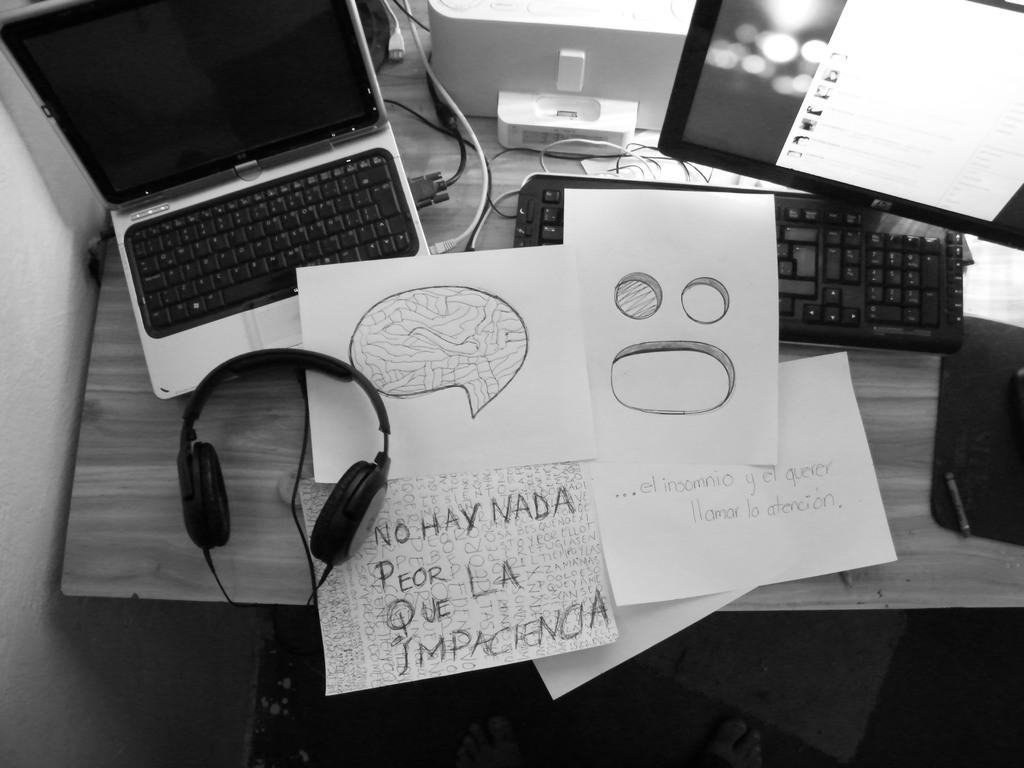Can you describe this image briefly? In this image I can see a laptop, a keyboard, a monitor, few papers and headphone on this table. 